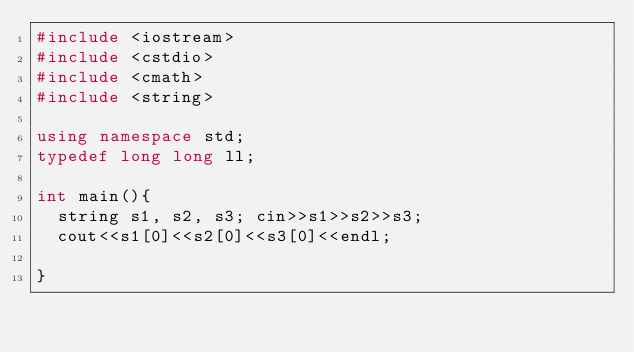Convert code to text. <code><loc_0><loc_0><loc_500><loc_500><_C++_>#include <iostream>
#include <cstdio>
#include <cmath>
#include <string>

using namespace std;
typedef long long ll;

int main(){
  string s1, s2, s3; cin>>s1>>s2>>s3;
  cout<<s1[0]<<s2[0]<<s3[0]<<endl;

}</code> 